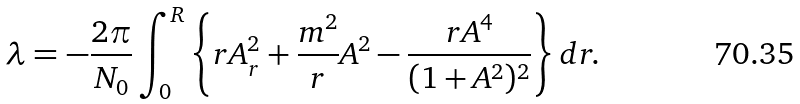<formula> <loc_0><loc_0><loc_500><loc_500>\lambda = - \frac { 2 \pi } { N _ { 0 } } \int _ { 0 } ^ { R } \left \{ r A _ { r } ^ { 2 } + \frac { m ^ { 2 } } { r } A ^ { 2 } - \frac { r A ^ { 4 } } { ( 1 + A ^ { 2 } ) ^ { 2 } } \right \} d r .</formula> 